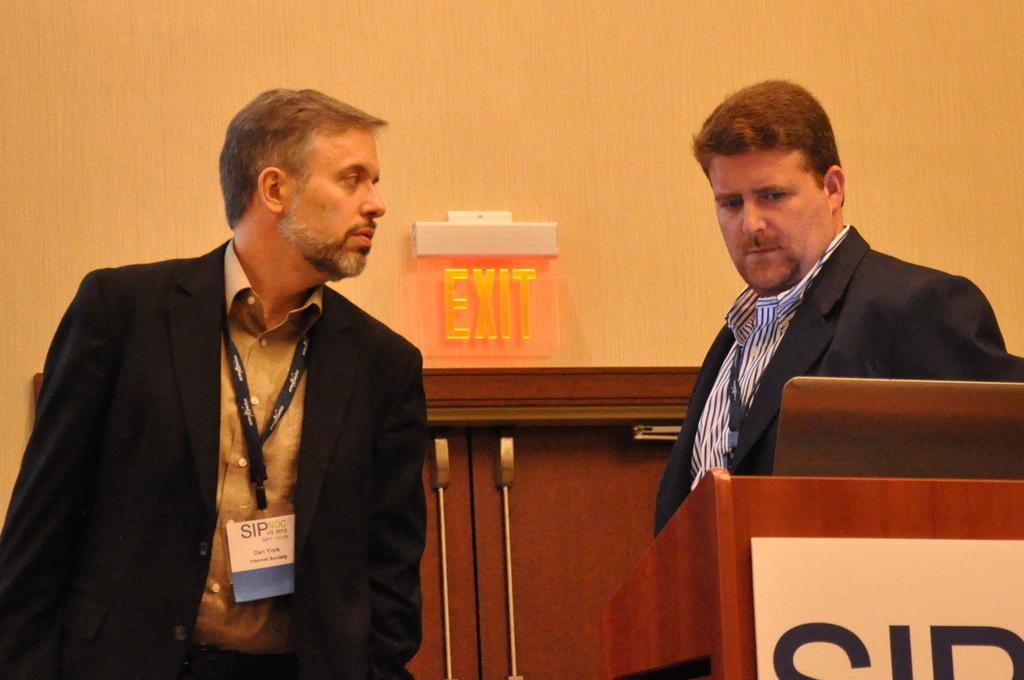Please provide a concise description of this image. In the image there are two men in the foreground and on the right side there is a table, in the background there is an exit door. 